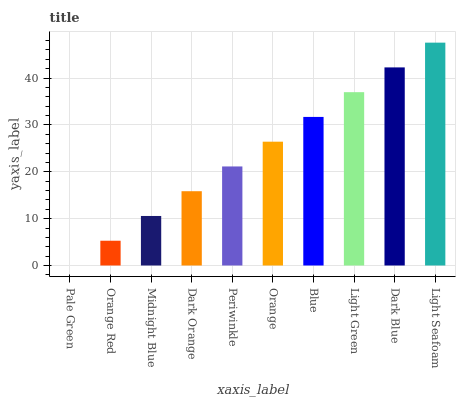Is Pale Green the minimum?
Answer yes or no. Yes. Is Light Seafoam the maximum?
Answer yes or no. Yes. Is Orange Red the minimum?
Answer yes or no. No. Is Orange Red the maximum?
Answer yes or no. No. Is Orange Red greater than Pale Green?
Answer yes or no. Yes. Is Pale Green less than Orange Red?
Answer yes or no. Yes. Is Pale Green greater than Orange Red?
Answer yes or no. No. Is Orange Red less than Pale Green?
Answer yes or no. No. Is Orange the high median?
Answer yes or no. Yes. Is Periwinkle the low median?
Answer yes or no. Yes. Is Blue the high median?
Answer yes or no. No. Is Pale Green the low median?
Answer yes or no. No. 